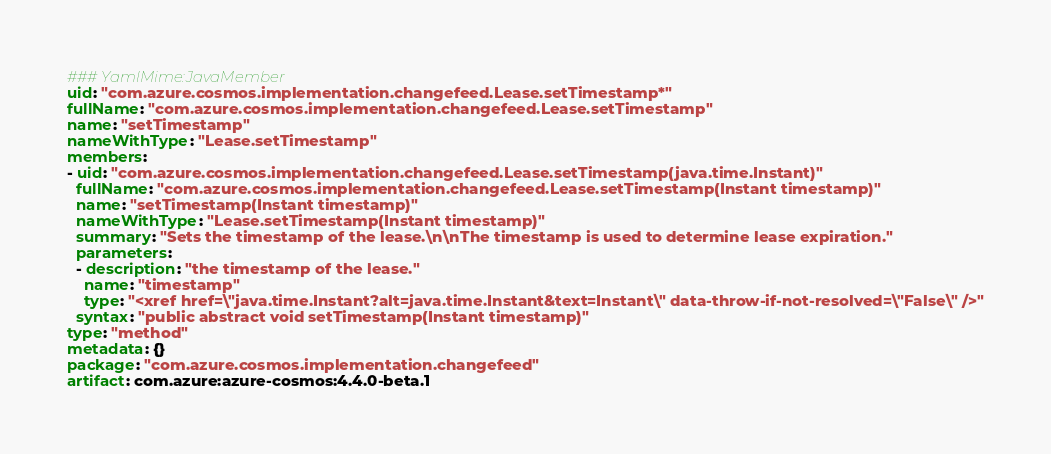<code> <loc_0><loc_0><loc_500><loc_500><_YAML_>### YamlMime:JavaMember
uid: "com.azure.cosmos.implementation.changefeed.Lease.setTimestamp*"
fullName: "com.azure.cosmos.implementation.changefeed.Lease.setTimestamp"
name: "setTimestamp"
nameWithType: "Lease.setTimestamp"
members:
- uid: "com.azure.cosmos.implementation.changefeed.Lease.setTimestamp(java.time.Instant)"
  fullName: "com.azure.cosmos.implementation.changefeed.Lease.setTimestamp(Instant timestamp)"
  name: "setTimestamp(Instant timestamp)"
  nameWithType: "Lease.setTimestamp(Instant timestamp)"
  summary: "Sets the timestamp of the lease.\n\nThe timestamp is used to determine lease expiration."
  parameters:
  - description: "the timestamp of the lease."
    name: "timestamp"
    type: "<xref href=\"java.time.Instant?alt=java.time.Instant&text=Instant\" data-throw-if-not-resolved=\"False\" />"
  syntax: "public abstract void setTimestamp(Instant timestamp)"
type: "method"
metadata: {}
package: "com.azure.cosmos.implementation.changefeed"
artifact: com.azure:azure-cosmos:4.4.0-beta.1
</code> 